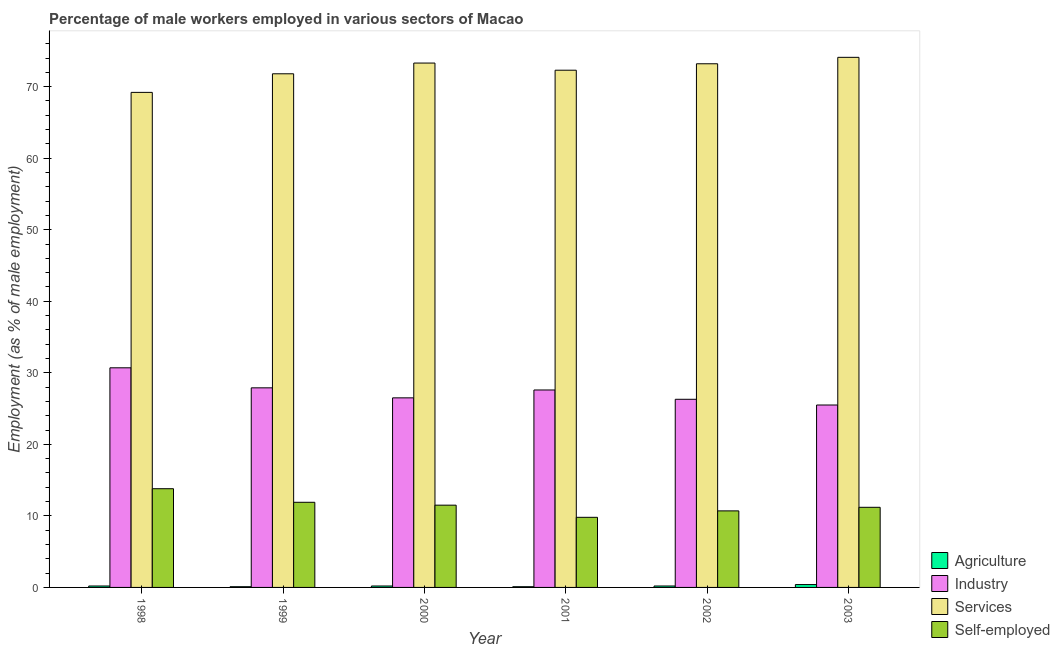How many different coloured bars are there?
Make the answer very short. 4. How many groups of bars are there?
Ensure brevity in your answer.  6. Are the number of bars per tick equal to the number of legend labels?
Offer a very short reply. Yes. Are the number of bars on each tick of the X-axis equal?
Make the answer very short. Yes. What is the label of the 6th group of bars from the left?
Provide a succinct answer. 2003. In how many cases, is the number of bars for a given year not equal to the number of legend labels?
Give a very brief answer. 0. What is the percentage of male workers in services in 2003?
Provide a succinct answer. 74.1. Across all years, what is the maximum percentage of male workers in agriculture?
Provide a succinct answer. 0.4. Across all years, what is the minimum percentage of male workers in industry?
Offer a very short reply. 25.5. In which year was the percentage of male workers in agriculture maximum?
Ensure brevity in your answer.  2003. In which year was the percentage of self employed male workers minimum?
Your answer should be very brief. 2001. What is the total percentage of male workers in industry in the graph?
Your answer should be compact. 164.5. What is the difference between the percentage of male workers in services in 1998 and that in 2003?
Make the answer very short. -4.9. What is the average percentage of male workers in industry per year?
Make the answer very short. 27.42. What is the ratio of the percentage of self employed male workers in 2001 to that in 2003?
Give a very brief answer. 0.88. Is the percentage of male workers in services in 1999 less than that in 2002?
Make the answer very short. Yes. What is the difference between the highest and the second highest percentage of male workers in services?
Your answer should be compact. 0.8. What is the difference between the highest and the lowest percentage of male workers in services?
Ensure brevity in your answer.  4.9. Is the sum of the percentage of male workers in industry in 1999 and 2001 greater than the maximum percentage of male workers in agriculture across all years?
Provide a short and direct response. Yes. What does the 1st bar from the left in 2001 represents?
Your answer should be compact. Agriculture. What does the 2nd bar from the right in 1998 represents?
Your answer should be very brief. Services. Is it the case that in every year, the sum of the percentage of male workers in agriculture and percentage of male workers in industry is greater than the percentage of male workers in services?
Offer a very short reply. No. Are all the bars in the graph horizontal?
Provide a succinct answer. No. How many years are there in the graph?
Provide a succinct answer. 6. What is the difference between two consecutive major ticks on the Y-axis?
Your answer should be very brief. 10. Are the values on the major ticks of Y-axis written in scientific E-notation?
Provide a short and direct response. No. Where does the legend appear in the graph?
Your answer should be compact. Bottom right. How many legend labels are there?
Offer a terse response. 4. How are the legend labels stacked?
Your answer should be compact. Vertical. What is the title of the graph?
Your answer should be compact. Percentage of male workers employed in various sectors of Macao. Does "Structural Policies" appear as one of the legend labels in the graph?
Offer a terse response. No. What is the label or title of the X-axis?
Give a very brief answer. Year. What is the label or title of the Y-axis?
Your response must be concise. Employment (as % of male employment). What is the Employment (as % of male employment) of Agriculture in 1998?
Offer a very short reply. 0.2. What is the Employment (as % of male employment) in Industry in 1998?
Keep it short and to the point. 30.7. What is the Employment (as % of male employment) of Services in 1998?
Make the answer very short. 69.2. What is the Employment (as % of male employment) of Self-employed in 1998?
Your answer should be very brief. 13.8. What is the Employment (as % of male employment) of Agriculture in 1999?
Your answer should be compact. 0.1. What is the Employment (as % of male employment) of Industry in 1999?
Make the answer very short. 27.9. What is the Employment (as % of male employment) in Services in 1999?
Ensure brevity in your answer.  71.8. What is the Employment (as % of male employment) of Self-employed in 1999?
Make the answer very short. 11.9. What is the Employment (as % of male employment) of Agriculture in 2000?
Ensure brevity in your answer.  0.2. What is the Employment (as % of male employment) of Industry in 2000?
Keep it short and to the point. 26.5. What is the Employment (as % of male employment) in Services in 2000?
Offer a very short reply. 73.3. What is the Employment (as % of male employment) in Agriculture in 2001?
Your answer should be very brief. 0.1. What is the Employment (as % of male employment) of Industry in 2001?
Offer a terse response. 27.6. What is the Employment (as % of male employment) of Services in 2001?
Your answer should be very brief. 72.3. What is the Employment (as % of male employment) of Self-employed in 2001?
Your answer should be very brief. 9.8. What is the Employment (as % of male employment) of Agriculture in 2002?
Provide a succinct answer. 0.2. What is the Employment (as % of male employment) in Industry in 2002?
Give a very brief answer. 26.3. What is the Employment (as % of male employment) of Services in 2002?
Ensure brevity in your answer.  73.2. What is the Employment (as % of male employment) of Self-employed in 2002?
Your answer should be compact. 10.7. What is the Employment (as % of male employment) in Agriculture in 2003?
Offer a terse response. 0.4. What is the Employment (as % of male employment) of Services in 2003?
Make the answer very short. 74.1. What is the Employment (as % of male employment) of Self-employed in 2003?
Give a very brief answer. 11.2. Across all years, what is the maximum Employment (as % of male employment) of Agriculture?
Keep it short and to the point. 0.4. Across all years, what is the maximum Employment (as % of male employment) in Industry?
Provide a short and direct response. 30.7. Across all years, what is the maximum Employment (as % of male employment) of Services?
Ensure brevity in your answer.  74.1. Across all years, what is the maximum Employment (as % of male employment) of Self-employed?
Provide a succinct answer. 13.8. Across all years, what is the minimum Employment (as % of male employment) of Agriculture?
Offer a very short reply. 0.1. Across all years, what is the minimum Employment (as % of male employment) of Services?
Keep it short and to the point. 69.2. Across all years, what is the minimum Employment (as % of male employment) in Self-employed?
Your response must be concise. 9.8. What is the total Employment (as % of male employment) of Industry in the graph?
Offer a terse response. 164.5. What is the total Employment (as % of male employment) in Services in the graph?
Provide a succinct answer. 433.9. What is the total Employment (as % of male employment) of Self-employed in the graph?
Your answer should be compact. 68.9. What is the difference between the Employment (as % of male employment) in Agriculture in 1998 and that in 1999?
Offer a terse response. 0.1. What is the difference between the Employment (as % of male employment) of Industry in 1998 and that in 1999?
Make the answer very short. 2.8. What is the difference between the Employment (as % of male employment) of Services in 1998 and that in 1999?
Provide a short and direct response. -2.6. What is the difference between the Employment (as % of male employment) in Self-employed in 1998 and that in 1999?
Your answer should be very brief. 1.9. What is the difference between the Employment (as % of male employment) of Agriculture in 1998 and that in 2000?
Your answer should be compact. 0. What is the difference between the Employment (as % of male employment) in Services in 1998 and that in 2000?
Your response must be concise. -4.1. What is the difference between the Employment (as % of male employment) in Self-employed in 1998 and that in 2001?
Ensure brevity in your answer.  4. What is the difference between the Employment (as % of male employment) of Agriculture in 1998 and that in 2002?
Your response must be concise. 0. What is the difference between the Employment (as % of male employment) in Industry in 1998 and that in 2002?
Your answer should be very brief. 4.4. What is the difference between the Employment (as % of male employment) of Services in 1998 and that in 2002?
Ensure brevity in your answer.  -4. What is the difference between the Employment (as % of male employment) of Self-employed in 1998 and that in 2002?
Provide a succinct answer. 3.1. What is the difference between the Employment (as % of male employment) of Agriculture in 1998 and that in 2003?
Provide a succinct answer. -0.2. What is the difference between the Employment (as % of male employment) in Services in 1998 and that in 2003?
Make the answer very short. -4.9. What is the difference between the Employment (as % of male employment) in Agriculture in 1999 and that in 2000?
Your answer should be very brief. -0.1. What is the difference between the Employment (as % of male employment) of Services in 1999 and that in 2000?
Offer a terse response. -1.5. What is the difference between the Employment (as % of male employment) in Agriculture in 1999 and that in 2001?
Ensure brevity in your answer.  0. What is the difference between the Employment (as % of male employment) in Industry in 1999 and that in 2001?
Provide a short and direct response. 0.3. What is the difference between the Employment (as % of male employment) of Services in 1999 and that in 2001?
Offer a very short reply. -0.5. What is the difference between the Employment (as % of male employment) in Self-employed in 1999 and that in 2002?
Your answer should be compact. 1.2. What is the difference between the Employment (as % of male employment) of Agriculture in 1999 and that in 2003?
Give a very brief answer. -0.3. What is the difference between the Employment (as % of male employment) in Industry in 1999 and that in 2003?
Offer a very short reply. 2.4. What is the difference between the Employment (as % of male employment) in Services in 1999 and that in 2003?
Ensure brevity in your answer.  -2.3. What is the difference between the Employment (as % of male employment) in Self-employed in 1999 and that in 2003?
Keep it short and to the point. 0.7. What is the difference between the Employment (as % of male employment) in Agriculture in 2000 and that in 2001?
Provide a short and direct response. 0.1. What is the difference between the Employment (as % of male employment) in Services in 2000 and that in 2001?
Ensure brevity in your answer.  1. What is the difference between the Employment (as % of male employment) in Agriculture in 2000 and that in 2002?
Make the answer very short. 0. What is the difference between the Employment (as % of male employment) of Industry in 2000 and that in 2002?
Make the answer very short. 0.2. What is the difference between the Employment (as % of male employment) of Services in 2000 and that in 2002?
Provide a succinct answer. 0.1. What is the difference between the Employment (as % of male employment) of Self-employed in 2000 and that in 2002?
Provide a succinct answer. 0.8. What is the difference between the Employment (as % of male employment) in Agriculture in 2000 and that in 2003?
Your response must be concise. -0.2. What is the difference between the Employment (as % of male employment) in Industry in 2000 and that in 2003?
Ensure brevity in your answer.  1. What is the difference between the Employment (as % of male employment) in Services in 2000 and that in 2003?
Provide a short and direct response. -0.8. What is the difference between the Employment (as % of male employment) of Self-employed in 2000 and that in 2003?
Make the answer very short. 0.3. What is the difference between the Employment (as % of male employment) in Services in 2001 and that in 2002?
Your answer should be very brief. -0.9. What is the difference between the Employment (as % of male employment) of Agriculture in 2001 and that in 2003?
Your answer should be compact. -0.3. What is the difference between the Employment (as % of male employment) of Industry in 2001 and that in 2003?
Provide a succinct answer. 2.1. What is the difference between the Employment (as % of male employment) of Services in 2001 and that in 2003?
Provide a short and direct response. -1.8. What is the difference between the Employment (as % of male employment) of Self-employed in 2001 and that in 2003?
Your answer should be compact. -1.4. What is the difference between the Employment (as % of male employment) in Agriculture in 2002 and that in 2003?
Offer a terse response. -0.2. What is the difference between the Employment (as % of male employment) in Services in 2002 and that in 2003?
Keep it short and to the point. -0.9. What is the difference between the Employment (as % of male employment) of Self-employed in 2002 and that in 2003?
Offer a terse response. -0.5. What is the difference between the Employment (as % of male employment) in Agriculture in 1998 and the Employment (as % of male employment) in Industry in 1999?
Your answer should be very brief. -27.7. What is the difference between the Employment (as % of male employment) of Agriculture in 1998 and the Employment (as % of male employment) of Services in 1999?
Your answer should be very brief. -71.6. What is the difference between the Employment (as % of male employment) of Industry in 1998 and the Employment (as % of male employment) of Services in 1999?
Keep it short and to the point. -41.1. What is the difference between the Employment (as % of male employment) of Services in 1998 and the Employment (as % of male employment) of Self-employed in 1999?
Ensure brevity in your answer.  57.3. What is the difference between the Employment (as % of male employment) in Agriculture in 1998 and the Employment (as % of male employment) in Industry in 2000?
Offer a very short reply. -26.3. What is the difference between the Employment (as % of male employment) of Agriculture in 1998 and the Employment (as % of male employment) of Services in 2000?
Give a very brief answer. -73.1. What is the difference between the Employment (as % of male employment) in Agriculture in 1998 and the Employment (as % of male employment) in Self-employed in 2000?
Provide a succinct answer. -11.3. What is the difference between the Employment (as % of male employment) in Industry in 1998 and the Employment (as % of male employment) in Services in 2000?
Offer a very short reply. -42.6. What is the difference between the Employment (as % of male employment) of Industry in 1998 and the Employment (as % of male employment) of Self-employed in 2000?
Keep it short and to the point. 19.2. What is the difference between the Employment (as % of male employment) in Services in 1998 and the Employment (as % of male employment) in Self-employed in 2000?
Offer a terse response. 57.7. What is the difference between the Employment (as % of male employment) in Agriculture in 1998 and the Employment (as % of male employment) in Industry in 2001?
Your answer should be very brief. -27.4. What is the difference between the Employment (as % of male employment) in Agriculture in 1998 and the Employment (as % of male employment) in Services in 2001?
Your response must be concise. -72.1. What is the difference between the Employment (as % of male employment) in Agriculture in 1998 and the Employment (as % of male employment) in Self-employed in 2001?
Make the answer very short. -9.6. What is the difference between the Employment (as % of male employment) in Industry in 1998 and the Employment (as % of male employment) in Services in 2001?
Ensure brevity in your answer.  -41.6. What is the difference between the Employment (as % of male employment) in Industry in 1998 and the Employment (as % of male employment) in Self-employed in 2001?
Your answer should be very brief. 20.9. What is the difference between the Employment (as % of male employment) of Services in 1998 and the Employment (as % of male employment) of Self-employed in 2001?
Keep it short and to the point. 59.4. What is the difference between the Employment (as % of male employment) in Agriculture in 1998 and the Employment (as % of male employment) in Industry in 2002?
Your response must be concise. -26.1. What is the difference between the Employment (as % of male employment) in Agriculture in 1998 and the Employment (as % of male employment) in Services in 2002?
Ensure brevity in your answer.  -73. What is the difference between the Employment (as % of male employment) of Agriculture in 1998 and the Employment (as % of male employment) of Self-employed in 2002?
Provide a succinct answer. -10.5. What is the difference between the Employment (as % of male employment) of Industry in 1998 and the Employment (as % of male employment) of Services in 2002?
Offer a very short reply. -42.5. What is the difference between the Employment (as % of male employment) of Services in 1998 and the Employment (as % of male employment) of Self-employed in 2002?
Your answer should be compact. 58.5. What is the difference between the Employment (as % of male employment) of Agriculture in 1998 and the Employment (as % of male employment) of Industry in 2003?
Provide a short and direct response. -25.3. What is the difference between the Employment (as % of male employment) in Agriculture in 1998 and the Employment (as % of male employment) in Services in 2003?
Your answer should be very brief. -73.9. What is the difference between the Employment (as % of male employment) in Agriculture in 1998 and the Employment (as % of male employment) in Self-employed in 2003?
Your answer should be compact. -11. What is the difference between the Employment (as % of male employment) of Industry in 1998 and the Employment (as % of male employment) of Services in 2003?
Provide a short and direct response. -43.4. What is the difference between the Employment (as % of male employment) of Industry in 1998 and the Employment (as % of male employment) of Self-employed in 2003?
Your response must be concise. 19.5. What is the difference between the Employment (as % of male employment) in Agriculture in 1999 and the Employment (as % of male employment) in Industry in 2000?
Make the answer very short. -26.4. What is the difference between the Employment (as % of male employment) of Agriculture in 1999 and the Employment (as % of male employment) of Services in 2000?
Your response must be concise. -73.2. What is the difference between the Employment (as % of male employment) in Industry in 1999 and the Employment (as % of male employment) in Services in 2000?
Offer a very short reply. -45.4. What is the difference between the Employment (as % of male employment) in Services in 1999 and the Employment (as % of male employment) in Self-employed in 2000?
Keep it short and to the point. 60.3. What is the difference between the Employment (as % of male employment) of Agriculture in 1999 and the Employment (as % of male employment) of Industry in 2001?
Your answer should be very brief. -27.5. What is the difference between the Employment (as % of male employment) in Agriculture in 1999 and the Employment (as % of male employment) in Services in 2001?
Give a very brief answer. -72.2. What is the difference between the Employment (as % of male employment) of Industry in 1999 and the Employment (as % of male employment) of Services in 2001?
Keep it short and to the point. -44.4. What is the difference between the Employment (as % of male employment) in Industry in 1999 and the Employment (as % of male employment) in Self-employed in 2001?
Your response must be concise. 18.1. What is the difference between the Employment (as % of male employment) of Agriculture in 1999 and the Employment (as % of male employment) of Industry in 2002?
Provide a succinct answer. -26.2. What is the difference between the Employment (as % of male employment) in Agriculture in 1999 and the Employment (as % of male employment) in Services in 2002?
Your response must be concise. -73.1. What is the difference between the Employment (as % of male employment) in Agriculture in 1999 and the Employment (as % of male employment) in Self-employed in 2002?
Ensure brevity in your answer.  -10.6. What is the difference between the Employment (as % of male employment) of Industry in 1999 and the Employment (as % of male employment) of Services in 2002?
Provide a succinct answer. -45.3. What is the difference between the Employment (as % of male employment) in Industry in 1999 and the Employment (as % of male employment) in Self-employed in 2002?
Ensure brevity in your answer.  17.2. What is the difference between the Employment (as % of male employment) in Services in 1999 and the Employment (as % of male employment) in Self-employed in 2002?
Make the answer very short. 61.1. What is the difference between the Employment (as % of male employment) of Agriculture in 1999 and the Employment (as % of male employment) of Industry in 2003?
Provide a succinct answer. -25.4. What is the difference between the Employment (as % of male employment) of Agriculture in 1999 and the Employment (as % of male employment) of Services in 2003?
Your answer should be very brief. -74. What is the difference between the Employment (as % of male employment) in Industry in 1999 and the Employment (as % of male employment) in Services in 2003?
Keep it short and to the point. -46.2. What is the difference between the Employment (as % of male employment) in Industry in 1999 and the Employment (as % of male employment) in Self-employed in 2003?
Offer a very short reply. 16.7. What is the difference between the Employment (as % of male employment) in Services in 1999 and the Employment (as % of male employment) in Self-employed in 2003?
Provide a succinct answer. 60.6. What is the difference between the Employment (as % of male employment) of Agriculture in 2000 and the Employment (as % of male employment) of Industry in 2001?
Provide a short and direct response. -27.4. What is the difference between the Employment (as % of male employment) in Agriculture in 2000 and the Employment (as % of male employment) in Services in 2001?
Offer a terse response. -72.1. What is the difference between the Employment (as % of male employment) of Industry in 2000 and the Employment (as % of male employment) of Services in 2001?
Make the answer very short. -45.8. What is the difference between the Employment (as % of male employment) in Industry in 2000 and the Employment (as % of male employment) in Self-employed in 2001?
Ensure brevity in your answer.  16.7. What is the difference between the Employment (as % of male employment) of Services in 2000 and the Employment (as % of male employment) of Self-employed in 2001?
Make the answer very short. 63.5. What is the difference between the Employment (as % of male employment) of Agriculture in 2000 and the Employment (as % of male employment) of Industry in 2002?
Your response must be concise. -26.1. What is the difference between the Employment (as % of male employment) in Agriculture in 2000 and the Employment (as % of male employment) in Services in 2002?
Provide a short and direct response. -73. What is the difference between the Employment (as % of male employment) in Agriculture in 2000 and the Employment (as % of male employment) in Self-employed in 2002?
Make the answer very short. -10.5. What is the difference between the Employment (as % of male employment) of Industry in 2000 and the Employment (as % of male employment) of Services in 2002?
Your answer should be compact. -46.7. What is the difference between the Employment (as % of male employment) of Industry in 2000 and the Employment (as % of male employment) of Self-employed in 2002?
Offer a very short reply. 15.8. What is the difference between the Employment (as % of male employment) of Services in 2000 and the Employment (as % of male employment) of Self-employed in 2002?
Offer a very short reply. 62.6. What is the difference between the Employment (as % of male employment) of Agriculture in 2000 and the Employment (as % of male employment) of Industry in 2003?
Make the answer very short. -25.3. What is the difference between the Employment (as % of male employment) in Agriculture in 2000 and the Employment (as % of male employment) in Services in 2003?
Make the answer very short. -73.9. What is the difference between the Employment (as % of male employment) in Industry in 2000 and the Employment (as % of male employment) in Services in 2003?
Ensure brevity in your answer.  -47.6. What is the difference between the Employment (as % of male employment) of Industry in 2000 and the Employment (as % of male employment) of Self-employed in 2003?
Give a very brief answer. 15.3. What is the difference between the Employment (as % of male employment) in Services in 2000 and the Employment (as % of male employment) in Self-employed in 2003?
Your response must be concise. 62.1. What is the difference between the Employment (as % of male employment) in Agriculture in 2001 and the Employment (as % of male employment) in Industry in 2002?
Provide a short and direct response. -26.2. What is the difference between the Employment (as % of male employment) of Agriculture in 2001 and the Employment (as % of male employment) of Services in 2002?
Provide a short and direct response. -73.1. What is the difference between the Employment (as % of male employment) of Agriculture in 2001 and the Employment (as % of male employment) of Self-employed in 2002?
Give a very brief answer. -10.6. What is the difference between the Employment (as % of male employment) of Industry in 2001 and the Employment (as % of male employment) of Services in 2002?
Ensure brevity in your answer.  -45.6. What is the difference between the Employment (as % of male employment) in Industry in 2001 and the Employment (as % of male employment) in Self-employed in 2002?
Offer a terse response. 16.9. What is the difference between the Employment (as % of male employment) of Services in 2001 and the Employment (as % of male employment) of Self-employed in 2002?
Provide a short and direct response. 61.6. What is the difference between the Employment (as % of male employment) of Agriculture in 2001 and the Employment (as % of male employment) of Industry in 2003?
Make the answer very short. -25.4. What is the difference between the Employment (as % of male employment) of Agriculture in 2001 and the Employment (as % of male employment) of Services in 2003?
Offer a very short reply. -74. What is the difference between the Employment (as % of male employment) in Industry in 2001 and the Employment (as % of male employment) in Services in 2003?
Give a very brief answer. -46.5. What is the difference between the Employment (as % of male employment) in Industry in 2001 and the Employment (as % of male employment) in Self-employed in 2003?
Give a very brief answer. 16.4. What is the difference between the Employment (as % of male employment) of Services in 2001 and the Employment (as % of male employment) of Self-employed in 2003?
Ensure brevity in your answer.  61.1. What is the difference between the Employment (as % of male employment) of Agriculture in 2002 and the Employment (as % of male employment) of Industry in 2003?
Make the answer very short. -25.3. What is the difference between the Employment (as % of male employment) in Agriculture in 2002 and the Employment (as % of male employment) in Services in 2003?
Offer a terse response. -73.9. What is the difference between the Employment (as % of male employment) of Agriculture in 2002 and the Employment (as % of male employment) of Self-employed in 2003?
Provide a succinct answer. -11. What is the difference between the Employment (as % of male employment) in Industry in 2002 and the Employment (as % of male employment) in Services in 2003?
Make the answer very short. -47.8. What is the difference between the Employment (as % of male employment) of Industry in 2002 and the Employment (as % of male employment) of Self-employed in 2003?
Offer a terse response. 15.1. What is the difference between the Employment (as % of male employment) in Services in 2002 and the Employment (as % of male employment) in Self-employed in 2003?
Your answer should be very brief. 62. What is the average Employment (as % of male employment) in Industry per year?
Your answer should be very brief. 27.42. What is the average Employment (as % of male employment) of Services per year?
Offer a terse response. 72.32. What is the average Employment (as % of male employment) in Self-employed per year?
Offer a very short reply. 11.48. In the year 1998, what is the difference between the Employment (as % of male employment) of Agriculture and Employment (as % of male employment) of Industry?
Provide a succinct answer. -30.5. In the year 1998, what is the difference between the Employment (as % of male employment) in Agriculture and Employment (as % of male employment) in Services?
Ensure brevity in your answer.  -69. In the year 1998, what is the difference between the Employment (as % of male employment) in Agriculture and Employment (as % of male employment) in Self-employed?
Offer a very short reply. -13.6. In the year 1998, what is the difference between the Employment (as % of male employment) in Industry and Employment (as % of male employment) in Services?
Offer a terse response. -38.5. In the year 1998, what is the difference between the Employment (as % of male employment) in Services and Employment (as % of male employment) in Self-employed?
Keep it short and to the point. 55.4. In the year 1999, what is the difference between the Employment (as % of male employment) in Agriculture and Employment (as % of male employment) in Industry?
Keep it short and to the point. -27.8. In the year 1999, what is the difference between the Employment (as % of male employment) in Agriculture and Employment (as % of male employment) in Services?
Offer a very short reply. -71.7. In the year 1999, what is the difference between the Employment (as % of male employment) in Agriculture and Employment (as % of male employment) in Self-employed?
Provide a succinct answer. -11.8. In the year 1999, what is the difference between the Employment (as % of male employment) of Industry and Employment (as % of male employment) of Services?
Your answer should be compact. -43.9. In the year 1999, what is the difference between the Employment (as % of male employment) in Industry and Employment (as % of male employment) in Self-employed?
Your answer should be very brief. 16. In the year 1999, what is the difference between the Employment (as % of male employment) of Services and Employment (as % of male employment) of Self-employed?
Your answer should be compact. 59.9. In the year 2000, what is the difference between the Employment (as % of male employment) of Agriculture and Employment (as % of male employment) of Industry?
Your answer should be very brief. -26.3. In the year 2000, what is the difference between the Employment (as % of male employment) in Agriculture and Employment (as % of male employment) in Services?
Your answer should be very brief. -73.1. In the year 2000, what is the difference between the Employment (as % of male employment) in Industry and Employment (as % of male employment) in Services?
Your answer should be compact. -46.8. In the year 2000, what is the difference between the Employment (as % of male employment) in Industry and Employment (as % of male employment) in Self-employed?
Your response must be concise. 15. In the year 2000, what is the difference between the Employment (as % of male employment) of Services and Employment (as % of male employment) of Self-employed?
Your answer should be very brief. 61.8. In the year 2001, what is the difference between the Employment (as % of male employment) of Agriculture and Employment (as % of male employment) of Industry?
Your response must be concise. -27.5. In the year 2001, what is the difference between the Employment (as % of male employment) in Agriculture and Employment (as % of male employment) in Services?
Your response must be concise. -72.2. In the year 2001, what is the difference between the Employment (as % of male employment) of Industry and Employment (as % of male employment) of Services?
Offer a terse response. -44.7. In the year 2001, what is the difference between the Employment (as % of male employment) in Services and Employment (as % of male employment) in Self-employed?
Your answer should be compact. 62.5. In the year 2002, what is the difference between the Employment (as % of male employment) of Agriculture and Employment (as % of male employment) of Industry?
Make the answer very short. -26.1. In the year 2002, what is the difference between the Employment (as % of male employment) of Agriculture and Employment (as % of male employment) of Services?
Your response must be concise. -73. In the year 2002, what is the difference between the Employment (as % of male employment) in Agriculture and Employment (as % of male employment) in Self-employed?
Offer a terse response. -10.5. In the year 2002, what is the difference between the Employment (as % of male employment) in Industry and Employment (as % of male employment) in Services?
Keep it short and to the point. -46.9. In the year 2002, what is the difference between the Employment (as % of male employment) of Services and Employment (as % of male employment) of Self-employed?
Offer a terse response. 62.5. In the year 2003, what is the difference between the Employment (as % of male employment) of Agriculture and Employment (as % of male employment) of Industry?
Offer a terse response. -25.1. In the year 2003, what is the difference between the Employment (as % of male employment) in Agriculture and Employment (as % of male employment) in Services?
Make the answer very short. -73.7. In the year 2003, what is the difference between the Employment (as % of male employment) of Agriculture and Employment (as % of male employment) of Self-employed?
Keep it short and to the point. -10.8. In the year 2003, what is the difference between the Employment (as % of male employment) of Industry and Employment (as % of male employment) of Services?
Your response must be concise. -48.6. In the year 2003, what is the difference between the Employment (as % of male employment) of Services and Employment (as % of male employment) of Self-employed?
Make the answer very short. 62.9. What is the ratio of the Employment (as % of male employment) of Industry in 1998 to that in 1999?
Provide a short and direct response. 1.1. What is the ratio of the Employment (as % of male employment) of Services in 1998 to that in 1999?
Your response must be concise. 0.96. What is the ratio of the Employment (as % of male employment) of Self-employed in 1998 to that in 1999?
Your answer should be compact. 1.16. What is the ratio of the Employment (as % of male employment) of Industry in 1998 to that in 2000?
Ensure brevity in your answer.  1.16. What is the ratio of the Employment (as % of male employment) of Services in 1998 to that in 2000?
Keep it short and to the point. 0.94. What is the ratio of the Employment (as % of male employment) in Industry in 1998 to that in 2001?
Offer a very short reply. 1.11. What is the ratio of the Employment (as % of male employment) in Services in 1998 to that in 2001?
Offer a terse response. 0.96. What is the ratio of the Employment (as % of male employment) in Self-employed in 1998 to that in 2001?
Offer a terse response. 1.41. What is the ratio of the Employment (as % of male employment) in Industry in 1998 to that in 2002?
Your answer should be compact. 1.17. What is the ratio of the Employment (as % of male employment) of Services in 1998 to that in 2002?
Offer a very short reply. 0.95. What is the ratio of the Employment (as % of male employment) in Self-employed in 1998 to that in 2002?
Keep it short and to the point. 1.29. What is the ratio of the Employment (as % of male employment) of Industry in 1998 to that in 2003?
Ensure brevity in your answer.  1.2. What is the ratio of the Employment (as % of male employment) of Services in 1998 to that in 2003?
Offer a very short reply. 0.93. What is the ratio of the Employment (as % of male employment) in Self-employed in 1998 to that in 2003?
Give a very brief answer. 1.23. What is the ratio of the Employment (as % of male employment) in Industry in 1999 to that in 2000?
Offer a terse response. 1.05. What is the ratio of the Employment (as % of male employment) in Services in 1999 to that in 2000?
Provide a short and direct response. 0.98. What is the ratio of the Employment (as % of male employment) of Self-employed in 1999 to that in 2000?
Your answer should be very brief. 1.03. What is the ratio of the Employment (as % of male employment) of Industry in 1999 to that in 2001?
Your answer should be very brief. 1.01. What is the ratio of the Employment (as % of male employment) in Self-employed in 1999 to that in 2001?
Your answer should be very brief. 1.21. What is the ratio of the Employment (as % of male employment) in Industry in 1999 to that in 2002?
Ensure brevity in your answer.  1.06. What is the ratio of the Employment (as % of male employment) of Services in 1999 to that in 2002?
Your response must be concise. 0.98. What is the ratio of the Employment (as % of male employment) of Self-employed in 1999 to that in 2002?
Offer a terse response. 1.11. What is the ratio of the Employment (as % of male employment) of Industry in 1999 to that in 2003?
Provide a succinct answer. 1.09. What is the ratio of the Employment (as % of male employment) in Services in 1999 to that in 2003?
Offer a terse response. 0.97. What is the ratio of the Employment (as % of male employment) of Self-employed in 1999 to that in 2003?
Ensure brevity in your answer.  1.06. What is the ratio of the Employment (as % of male employment) in Industry in 2000 to that in 2001?
Provide a short and direct response. 0.96. What is the ratio of the Employment (as % of male employment) in Services in 2000 to that in 2001?
Give a very brief answer. 1.01. What is the ratio of the Employment (as % of male employment) of Self-employed in 2000 to that in 2001?
Provide a succinct answer. 1.17. What is the ratio of the Employment (as % of male employment) of Agriculture in 2000 to that in 2002?
Ensure brevity in your answer.  1. What is the ratio of the Employment (as % of male employment) in Industry in 2000 to that in 2002?
Ensure brevity in your answer.  1.01. What is the ratio of the Employment (as % of male employment) of Services in 2000 to that in 2002?
Provide a succinct answer. 1. What is the ratio of the Employment (as % of male employment) of Self-employed in 2000 to that in 2002?
Ensure brevity in your answer.  1.07. What is the ratio of the Employment (as % of male employment) in Agriculture in 2000 to that in 2003?
Keep it short and to the point. 0.5. What is the ratio of the Employment (as % of male employment) in Industry in 2000 to that in 2003?
Provide a short and direct response. 1.04. What is the ratio of the Employment (as % of male employment) in Services in 2000 to that in 2003?
Give a very brief answer. 0.99. What is the ratio of the Employment (as % of male employment) of Self-employed in 2000 to that in 2003?
Provide a short and direct response. 1.03. What is the ratio of the Employment (as % of male employment) of Industry in 2001 to that in 2002?
Make the answer very short. 1.05. What is the ratio of the Employment (as % of male employment) in Services in 2001 to that in 2002?
Offer a terse response. 0.99. What is the ratio of the Employment (as % of male employment) of Self-employed in 2001 to that in 2002?
Give a very brief answer. 0.92. What is the ratio of the Employment (as % of male employment) of Industry in 2001 to that in 2003?
Keep it short and to the point. 1.08. What is the ratio of the Employment (as % of male employment) in Services in 2001 to that in 2003?
Offer a very short reply. 0.98. What is the ratio of the Employment (as % of male employment) of Agriculture in 2002 to that in 2003?
Your response must be concise. 0.5. What is the ratio of the Employment (as % of male employment) in Industry in 2002 to that in 2003?
Offer a terse response. 1.03. What is the ratio of the Employment (as % of male employment) of Services in 2002 to that in 2003?
Provide a short and direct response. 0.99. What is the ratio of the Employment (as % of male employment) in Self-employed in 2002 to that in 2003?
Your answer should be compact. 0.96. What is the difference between the highest and the second highest Employment (as % of male employment) of Agriculture?
Make the answer very short. 0.2. What is the difference between the highest and the second highest Employment (as % of male employment) in Services?
Give a very brief answer. 0.8. What is the difference between the highest and the lowest Employment (as % of male employment) in Self-employed?
Give a very brief answer. 4. 